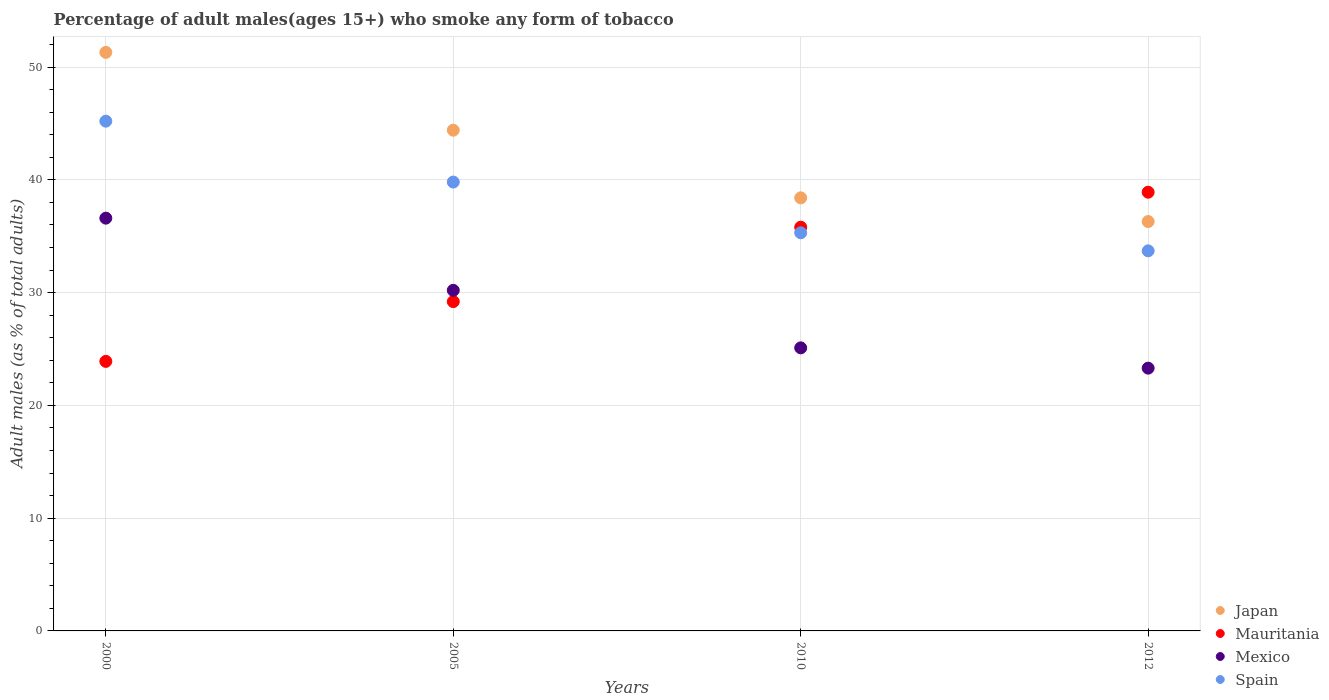Is the number of dotlines equal to the number of legend labels?
Give a very brief answer. Yes. What is the percentage of adult males who smoke in Mauritania in 2012?
Your response must be concise. 38.9. Across all years, what is the maximum percentage of adult males who smoke in Spain?
Your answer should be compact. 45.2. Across all years, what is the minimum percentage of adult males who smoke in Spain?
Keep it short and to the point. 33.7. In which year was the percentage of adult males who smoke in Spain maximum?
Ensure brevity in your answer.  2000. In which year was the percentage of adult males who smoke in Mauritania minimum?
Ensure brevity in your answer.  2000. What is the total percentage of adult males who smoke in Japan in the graph?
Provide a succinct answer. 170.4. What is the difference between the percentage of adult males who smoke in Spain in 2010 and that in 2012?
Provide a succinct answer. 1.6. What is the difference between the percentage of adult males who smoke in Mexico in 2005 and the percentage of adult males who smoke in Mauritania in 2012?
Give a very brief answer. -8.7. What is the average percentage of adult males who smoke in Mexico per year?
Keep it short and to the point. 28.8. In how many years, is the percentage of adult males who smoke in Spain greater than 50 %?
Make the answer very short. 0. What is the ratio of the percentage of adult males who smoke in Japan in 2005 to that in 2012?
Your response must be concise. 1.22. Is the difference between the percentage of adult males who smoke in Mexico in 2000 and 2005 greater than the difference between the percentage of adult males who smoke in Japan in 2000 and 2005?
Your answer should be very brief. No. What is the difference between the highest and the second highest percentage of adult males who smoke in Mauritania?
Your answer should be compact. 3.1. What is the difference between the highest and the lowest percentage of adult males who smoke in Mexico?
Keep it short and to the point. 13.3. Is the sum of the percentage of adult males who smoke in Japan in 2000 and 2010 greater than the maximum percentage of adult males who smoke in Spain across all years?
Give a very brief answer. Yes. Is the percentage of adult males who smoke in Mauritania strictly greater than the percentage of adult males who smoke in Spain over the years?
Provide a short and direct response. No. Is the percentage of adult males who smoke in Mauritania strictly less than the percentage of adult males who smoke in Japan over the years?
Keep it short and to the point. No. How many dotlines are there?
Offer a very short reply. 4. What is the difference between two consecutive major ticks on the Y-axis?
Your answer should be very brief. 10. Does the graph contain any zero values?
Make the answer very short. No. Does the graph contain grids?
Provide a succinct answer. Yes. Where does the legend appear in the graph?
Keep it short and to the point. Bottom right. How are the legend labels stacked?
Make the answer very short. Vertical. What is the title of the graph?
Your answer should be very brief. Percentage of adult males(ages 15+) who smoke any form of tobacco. What is the label or title of the X-axis?
Offer a terse response. Years. What is the label or title of the Y-axis?
Your answer should be compact. Adult males (as % of total adults). What is the Adult males (as % of total adults) of Japan in 2000?
Ensure brevity in your answer.  51.3. What is the Adult males (as % of total adults) of Mauritania in 2000?
Provide a succinct answer. 23.9. What is the Adult males (as % of total adults) of Mexico in 2000?
Provide a short and direct response. 36.6. What is the Adult males (as % of total adults) in Spain in 2000?
Ensure brevity in your answer.  45.2. What is the Adult males (as % of total adults) of Japan in 2005?
Provide a succinct answer. 44.4. What is the Adult males (as % of total adults) in Mauritania in 2005?
Offer a terse response. 29.2. What is the Adult males (as % of total adults) of Mexico in 2005?
Ensure brevity in your answer.  30.2. What is the Adult males (as % of total adults) of Spain in 2005?
Your answer should be compact. 39.8. What is the Adult males (as % of total adults) of Japan in 2010?
Offer a very short reply. 38.4. What is the Adult males (as % of total adults) in Mauritania in 2010?
Offer a very short reply. 35.8. What is the Adult males (as % of total adults) in Mexico in 2010?
Your answer should be compact. 25.1. What is the Adult males (as % of total adults) of Spain in 2010?
Your answer should be compact. 35.3. What is the Adult males (as % of total adults) of Japan in 2012?
Offer a very short reply. 36.3. What is the Adult males (as % of total adults) in Mauritania in 2012?
Offer a very short reply. 38.9. What is the Adult males (as % of total adults) of Mexico in 2012?
Your answer should be compact. 23.3. What is the Adult males (as % of total adults) in Spain in 2012?
Offer a very short reply. 33.7. Across all years, what is the maximum Adult males (as % of total adults) of Japan?
Make the answer very short. 51.3. Across all years, what is the maximum Adult males (as % of total adults) in Mauritania?
Your answer should be very brief. 38.9. Across all years, what is the maximum Adult males (as % of total adults) in Mexico?
Your answer should be compact. 36.6. Across all years, what is the maximum Adult males (as % of total adults) in Spain?
Your response must be concise. 45.2. Across all years, what is the minimum Adult males (as % of total adults) in Japan?
Make the answer very short. 36.3. Across all years, what is the minimum Adult males (as % of total adults) in Mauritania?
Your response must be concise. 23.9. Across all years, what is the minimum Adult males (as % of total adults) in Mexico?
Offer a terse response. 23.3. Across all years, what is the minimum Adult males (as % of total adults) of Spain?
Give a very brief answer. 33.7. What is the total Adult males (as % of total adults) in Japan in the graph?
Your response must be concise. 170.4. What is the total Adult males (as % of total adults) in Mauritania in the graph?
Ensure brevity in your answer.  127.8. What is the total Adult males (as % of total adults) in Mexico in the graph?
Give a very brief answer. 115.2. What is the total Adult males (as % of total adults) in Spain in the graph?
Provide a short and direct response. 154. What is the difference between the Adult males (as % of total adults) in Mexico in 2000 and that in 2005?
Make the answer very short. 6.4. What is the difference between the Adult males (as % of total adults) in Spain in 2000 and that in 2010?
Provide a succinct answer. 9.9. What is the difference between the Adult males (as % of total adults) in Mauritania in 2000 and that in 2012?
Provide a succinct answer. -15. What is the difference between the Adult males (as % of total adults) in Japan in 2005 and that in 2010?
Make the answer very short. 6. What is the difference between the Adult males (as % of total adults) in Mauritania in 2005 and that in 2012?
Your response must be concise. -9.7. What is the difference between the Adult males (as % of total adults) of Mexico in 2005 and that in 2012?
Give a very brief answer. 6.9. What is the difference between the Adult males (as % of total adults) in Mauritania in 2010 and that in 2012?
Ensure brevity in your answer.  -3.1. What is the difference between the Adult males (as % of total adults) in Spain in 2010 and that in 2012?
Offer a terse response. 1.6. What is the difference between the Adult males (as % of total adults) of Japan in 2000 and the Adult males (as % of total adults) of Mauritania in 2005?
Offer a terse response. 22.1. What is the difference between the Adult males (as % of total adults) in Japan in 2000 and the Adult males (as % of total adults) in Mexico in 2005?
Give a very brief answer. 21.1. What is the difference between the Adult males (as % of total adults) of Japan in 2000 and the Adult males (as % of total adults) of Spain in 2005?
Offer a terse response. 11.5. What is the difference between the Adult males (as % of total adults) of Mauritania in 2000 and the Adult males (as % of total adults) of Mexico in 2005?
Offer a terse response. -6.3. What is the difference between the Adult males (as % of total adults) of Mauritania in 2000 and the Adult males (as % of total adults) of Spain in 2005?
Your answer should be very brief. -15.9. What is the difference between the Adult males (as % of total adults) in Mexico in 2000 and the Adult males (as % of total adults) in Spain in 2005?
Your answer should be compact. -3.2. What is the difference between the Adult males (as % of total adults) of Japan in 2000 and the Adult males (as % of total adults) of Mexico in 2010?
Your answer should be compact. 26.2. What is the difference between the Adult males (as % of total adults) in Japan in 2000 and the Adult males (as % of total adults) in Spain in 2010?
Offer a very short reply. 16. What is the difference between the Adult males (as % of total adults) of Mauritania in 2000 and the Adult males (as % of total adults) of Spain in 2010?
Keep it short and to the point. -11.4. What is the difference between the Adult males (as % of total adults) of Japan in 2000 and the Adult males (as % of total adults) of Mauritania in 2012?
Offer a terse response. 12.4. What is the difference between the Adult males (as % of total adults) of Japan in 2000 and the Adult males (as % of total adults) of Mexico in 2012?
Your response must be concise. 28. What is the difference between the Adult males (as % of total adults) of Japan in 2000 and the Adult males (as % of total adults) of Spain in 2012?
Your answer should be compact. 17.6. What is the difference between the Adult males (as % of total adults) in Japan in 2005 and the Adult males (as % of total adults) in Mexico in 2010?
Provide a succinct answer. 19.3. What is the difference between the Adult males (as % of total adults) in Japan in 2005 and the Adult males (as % of total adults) in Spain in 2010?
Your answer should be compact. 9.1. What is the difference between the Adult males (as % of total adults) of Mexico in 2005 and the Adult males (as % of total adults) of Spain in 2010?
Offer a very short reply. -5.1. What is the difference between the Adult males (as % of total adults) in Japan in 2005 and the Adult males (as % of total adults) in Mauritania in 2012?
Offer a very short reply. 5.5. What is the difference between the Adult males (as % of total adults) in Japan in 2005 and the Adult males (as % of total adults) in Mexico in 2012?
Offer a terse response. 21.1. What is the difference between the Adult males (as % of total adults) in Japan in 2005 and the Adult males (as % of total adults) in Spain in 2012?
Give a very brief answer. 10.7. What is the difference between the Adult males (as % of total adults) of Mauritania in 2005 and the Adult males (as % of total adults) of Spain in 2012?
Your answer should be very brief. -4.5. What is the difference between the Adult males (as % of total adults) of Mexico in 2005 and the Adult males (as % of total adults) of Spain in 2012?
Your response must be concise. -3.5. What is the difference between the Adult males (as % of total adults) of Japan in 2010 and the Adult males (as % of total adults) of Spain in 2012?
Your answer should be compact. 4.7. What is the difference between the Adult males (as % of total adults) in Mauritania in 2010 and the Adult males (as % of total adults) in Mexico in 2012?
Offer a very short reply. 12.5. What is the average Adult males (as % of total adults) in Japan per year?
Provide a short and direct response. 42.6. What is the average Adult males (as % of total adults) of Mauritania per year?
Provide a short and direct response. 31.95. What is the average Adult males (as % of total adults) in Mexico per year?
Your answer should be very brief. 28.8. What is the average Adult males (as % of total adults) of Spain per year?
Make the answer very short. 38.5. In the year 2000, what is the difference between the Adult males (as % of total adults) of Japan and Adult males (as % of total adults) of Mauritania?
Offer a terse response. 27.4. In the year 2000, what is the difference between the Adult males (as % of total adults) in Japan and Adult males (as % of total adults) in Mexico?
Ensure brevity in your answer.  14.7. In the year 2000, what is the difference between the Adult males (as % of total adults) in Japan and Adult males (as % of total adults) in Spain?
Make the answer very short. 6.1. In the year 2000, what is the difference between the Adult males (as % of total adults) in Mauritania and Adult males (as % of total adults) in Spain?
Provide a short and direct response. -21.3. In the year 2000, what is the difference between the Adult males (as % of total adults) of Mexico and Adult males (as % of total adults) of Spain?
Your response must be concise. -8.6. In the year 2005, what is the difference between the Adult males (as % of total adults) in Japan and Adult males (as % of total adults) in Mauritania?
Give a very brief answer. 15.2. In the year 2005, what is the difference between the Adult males (as % of total adults) in Japan and Adult males (as % of total adults) in Mexico?
Make the answer very short. 14.2. In the year 2010, what is the difference between the Adult males (as % of total adults) of Japan and Adult males (as % of total adults) of Spain?
Ensure brevity in your answer.  3.1. In the year 2010, what is the difference between the Adult males (as % of total adults) of Mauritania and Adult males (as % of total adults) of Mexico?
Give a very brief answer. 10.7. In the year 2010, what is the difference between the Adult males (as % of total adults) in Mexico and Adult males (as % of total adults) in Spain?
Offer a very short reply. -10.2. In the year 2012, what is the difference between the Adult males (as % of total adults) in Japan and Adult males (as % of total adults) in Mexico?
Provide a short and direct response. 13. In the year 2012, what is the difference between the Adult males (as % of total adults) in Japan and Adult males (as % of total adults) in Spain?
Give a very brief answer. 2.6. In the year 2012, what is the difference between the Adult males (as % of total adults) in Mauritania and Adult males (as % of total adults) in Mexico?
Your response must be concise. 15.6. What is the ratio of the Adult males (as % of total adults) in Japan in 2000 to that in 2005?
Your answer should be very brief. 1.16. What is the ratio of the Adult males (as % of total adults) in Mauritania in 2000 to that in 2005?
Ensure brevity in your answer.  0.82. What is the ratio of the Adult males (as % of total adults) of Mexico in 2000 to that in 2005?
Provide a succinct answer. 1.21. What is the ratio of the Adult males (as % of total adults) in Spain in 2000 to that in 2005?
Offer a terse response. 1.14. What is the ratio of the Adult males (as % of total adults) of Japan in 2000 to that in 2010?
Offer a very short reply. 1.34. What is the ratio of the Adult males (as % of total adults) of Mauritania in 2000 to that in 2010?
Your answer should be very brief. 0.67. What is the ratio of the Adult males (as % of total adults) of Mexico in 2000 to that in 2010?
Your answer should be compact. 1.46. What is the ratio of the Adult males (as % of total adults) of Spain in 2000 to that in 2010?
Keep it short and to the point. 1.28. What is the ratio of the Adult males (as % of total adults) of Japan in 2000 to that in 2012?
Ensure brevity in your answer.  1.41. What is the ratio of the Adult males (as % of total adults) of Mauritania in 2000 to that in 2012?
Provide a succinct answer. 0.61. What is the ratio of the Adult males (as % of total adults) in Mexico in 2000 to that in 2012?
Keep it short and to the point. 1.57. What is the ratio of the Adult males (as % of total adults) in Spain in 2000 to that in 2012?
Give a very brief answer. 1.34. What is the ratio of the Adult males (as % of total adults) of Japan in 2005 to that in 2010?
Offer a very short reply. 1.16. What is the ratio of the Adult males (as % of total adults) in Mauritania in 2005 to that in 2010?
Give a very brief answer. 0.82. What is the ratio of the Adult males (as % of total adults) of Mexico in 2005 to that in 2010?
Your answer should be very brief. 1.2. What is the ratio of the Adult males (as % of total adults) of Spain in 2005 to that in 2010?
Give a very brief answer. 1.13. What is the ratio of the Adult males (as % of total adults) of Japan in 2005 to that in 2012?
Provide a short and direct response. 1.22. What is the ratio of the Adult males (as % of total adults) in Mauritania in 2005 to that in 2012?
Offer a terse response. 0.75. What is the ratio of the Adult males (as % of total adults) in Mexico in 2005 to that in 2012?
Give a very brief answer. 1.3. What is the ratio of the Adult males (as % of total adults) in Spain in 2005 to that in 2012?
Offer a very short reply. 1.18. What is the ratio of the Adult males (as % of total adults) of Japan in 2010 to that in 2012?
Give a very brief answer. 1.06. What is the ratio of the Adult males (as % of total adults) in Mauritania in 2010 to that in 2012?
Your answer should be very brief. 0.92. What is the ratio of the Adult males (as % of total adults) in Mexico in 2010 to that in 2012?
Provide a succinct answer. 1.08. What is the ratio of the Adult males (as % of total adults) of Spain in 2010 to that in 2012?
Ensure brevity in your answer.  1.05. What is the difference between the highest and the second highest Adult males (as % of total adults) in Mexico?
Your answer should be very brief. 6.4. What is the difference between the highest and the lowest Adult males (as % of total adults) of Mauritania?
Keep it short and to the point. 15. What is the difference between the highest and the lowest Adult males (as % of total adults) of Mexico?
Your answer should be compact. 13.3. 